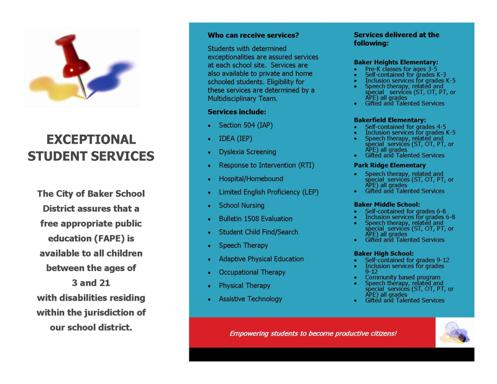Who can receive these services according to the information on the card? According to the card, services are accessible to all children with disabilities, ages 3 to 21, within the City of Baker School District. This inclusive approach ensures that every child, regardless of whether they attend public or private schools, or are home-schooled, can access the necessary support services at any school within the district, thus upholding their right to a free and appropriate public education. 